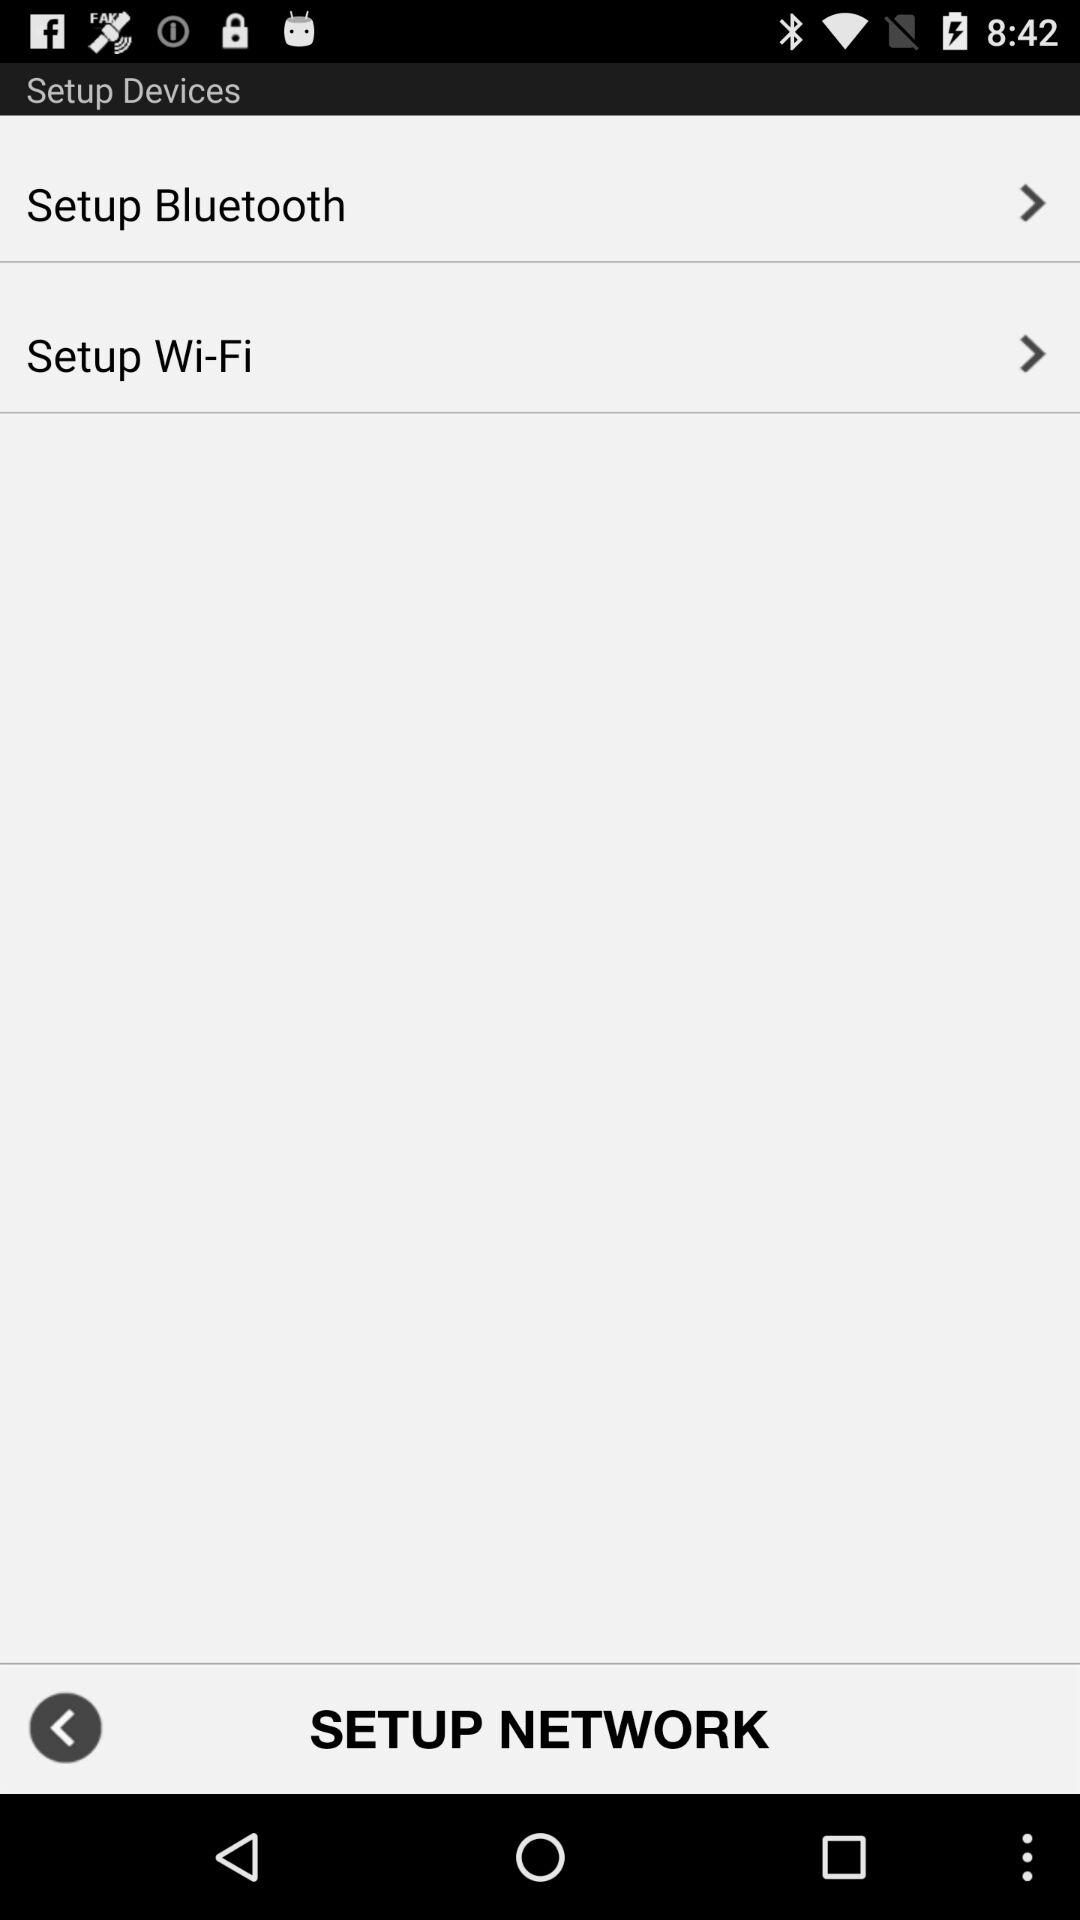How many Setup items are there in total?
Answer the question using a single word or phrase. 2 